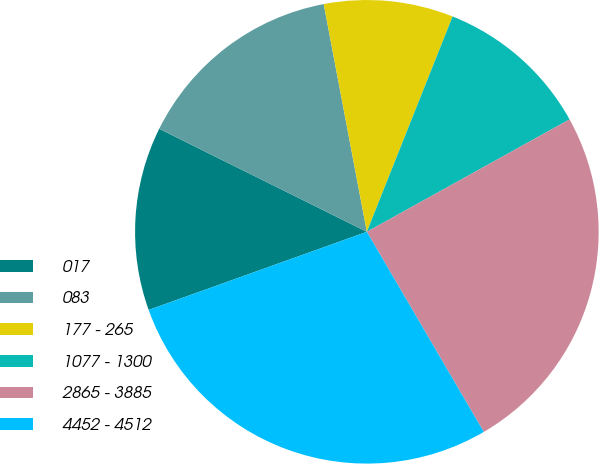Convert chart to OTSL. <chart><loc_0><loc_0><loc_500><loc_500><pie_chart><fcel>017<fcel>083<fcel>177 - 265<fcel>1077 - 1300<fcel>2865 - 3885<fcel>4452 - 4512<nl><fcel>12.8%<fcel>14.69%<fcel>9.01%<fcel>10.91%<fcel>24.64%<fcel>27.94%<nl></chart> 